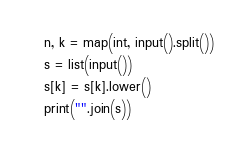<code> <loc_0><loc_0><loc_500><loc_500><_Python_>n, k = map(int, input().split())
s = list(input())
s[k] = s[k].lower()
print("".join(s))</code> 